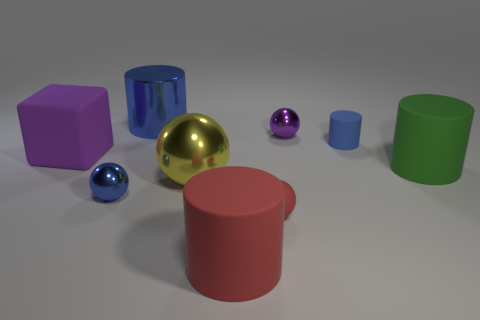What is the material of the large object on the right side of the blue rubber thing?
Make the answer very short. Rubber. What size is the red object that is the same shape as the large green thing?
Offer a very short reply. Large. What number of yellow spheres have the same material as the large yellow object?
Ensure brevity in your answer.  0. What number of matte cylinders have the same color as the large metal sphere?
Provide a succinct answer. 0. How many objects are either big green objects that are in front of the tiny matte cylinder or metal things on the left side of the tiny purple thing?
Give a very brief answer. 4. Are there fewer rubber cylinders behind the big shiny ball than blocks?
Give a very brief answer. No. Are there any yellow metallic objects of the same size as the yellow metal ball?
Offer a very short reply. No. The matte block has what color?
Offer a very short reply. Purple. Is the red cylinder the same size as the purple metal ball?
Your answer should be very brief. No. How many things are either large purple matte cubes or small cyan cubes?
Keep it short and to the point. 1. 